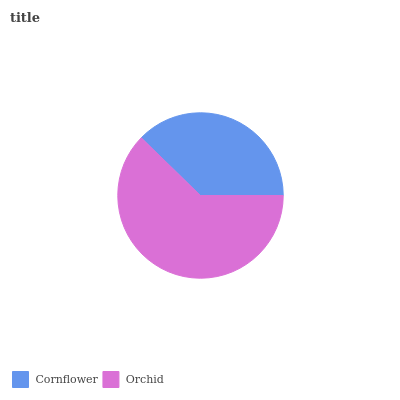Is Cornflower the minimum?
Answer yes or no. Yes. Is Orchid the maximum?
Answer yes or no. Yes. Is Orchid the minimum?
Answer yes or no. No. Is Orchid greater than Cornflower?
Answer yes or no. Yes. Is Cornflower less than Orchid?
Answer yes or no. Yes. Is Cornflower greater than Orchid?
Answer yes or no. No. Is Orchid less than Cornflower?
Answer yes or no. No. Is Orchid the high median?
Answer yes or no. Yes. Is Cornflower the low median?
Answer yes or no. Yes. Is Cornflower the high median?
Answer yes or no. No. Is Orchid the low median?
Answer yes or no. No. 